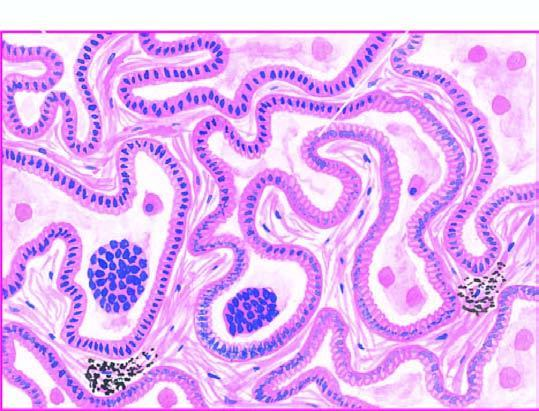re the alveolar walls lined by cuboidal to tall columnar and mucin-secreting tumour cells with papillary growth pattern?
Answer the question using a single word or phrase. Yes 